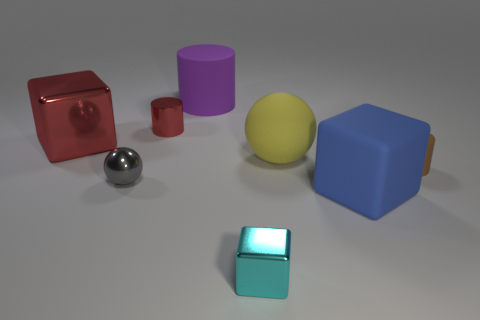Add 1 red cubes. How many objects exist? 9 Subtract all blocks. How many objects are left? 5 Add 5 big spheres. How many big spheres exist? 6 Subtract 0 purple spheres. How many objects are left? 8 Subtract all tiny brown rubber cylinders. Subtract all tiny red shiny things. How many objects are left? 6 Add 5 big cubes. How many big cubes are left? 7 